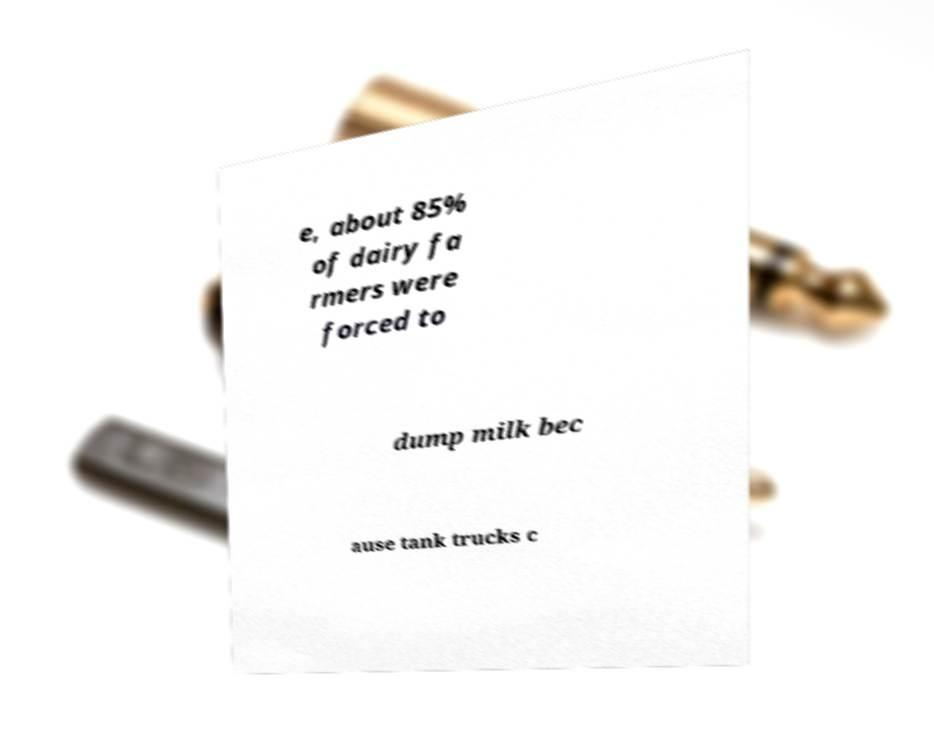Please read and relay the text visible in this image. What does it say? e, about 85% of dairy fa rmers were forced to dump milk bec ause tank trucks c 